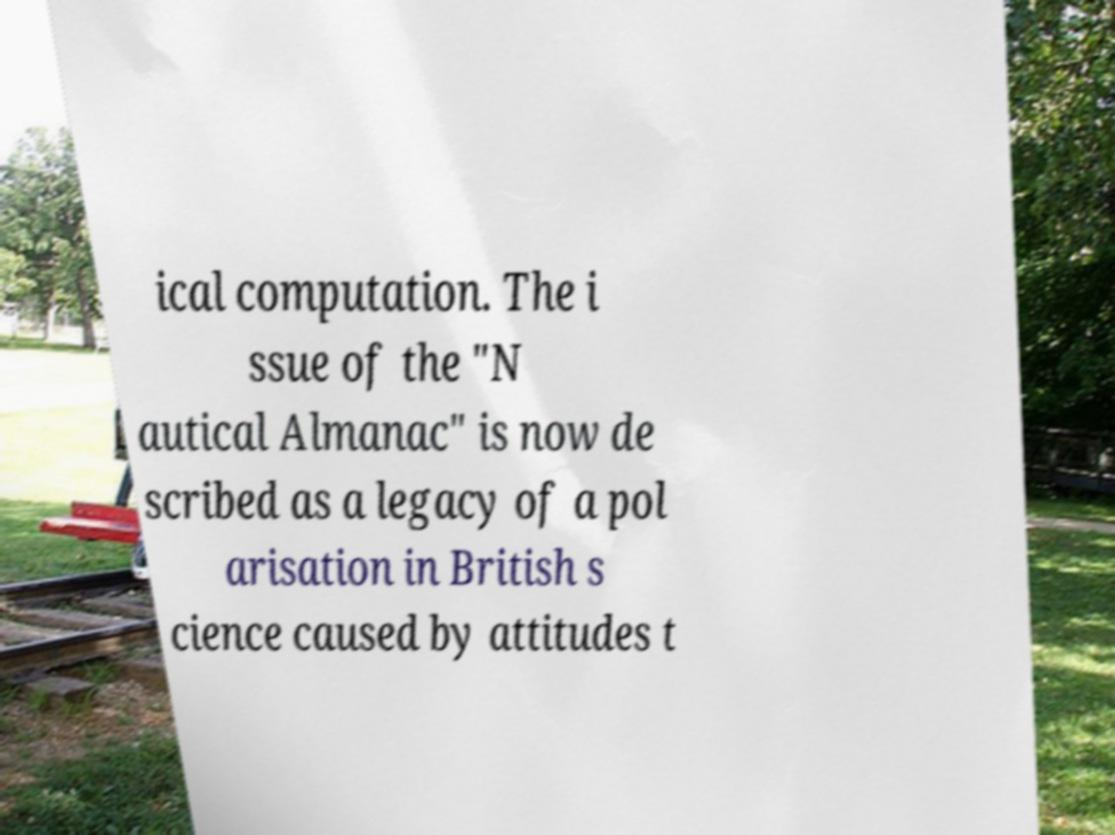I need the written content from this picture converted into text. Can you do that? ical computation. The i ssue of the "N autical Almanac" is now de scribed as a legacy of a pol arisation in British s cience caused by attitudes t 